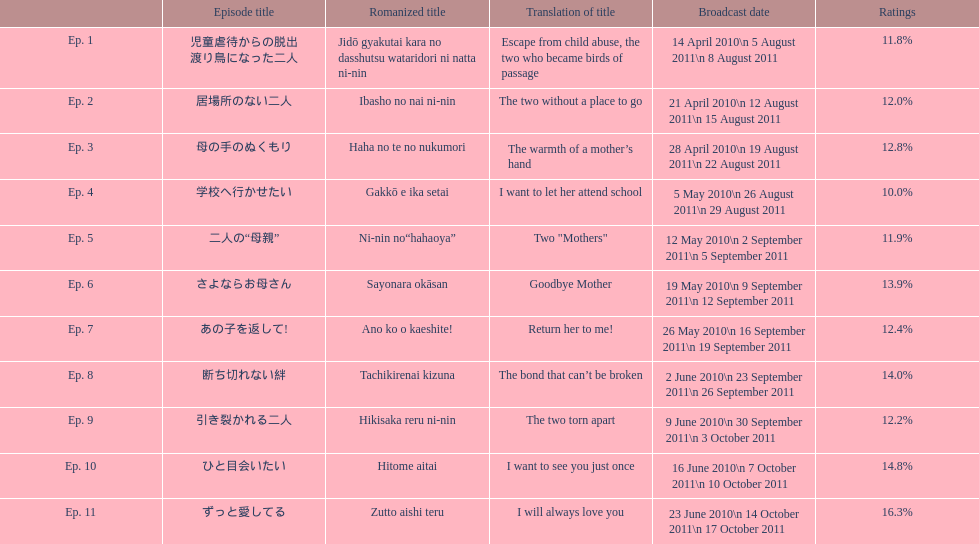What was the percent aggregate of ratings for episode 8? 14.0%. 